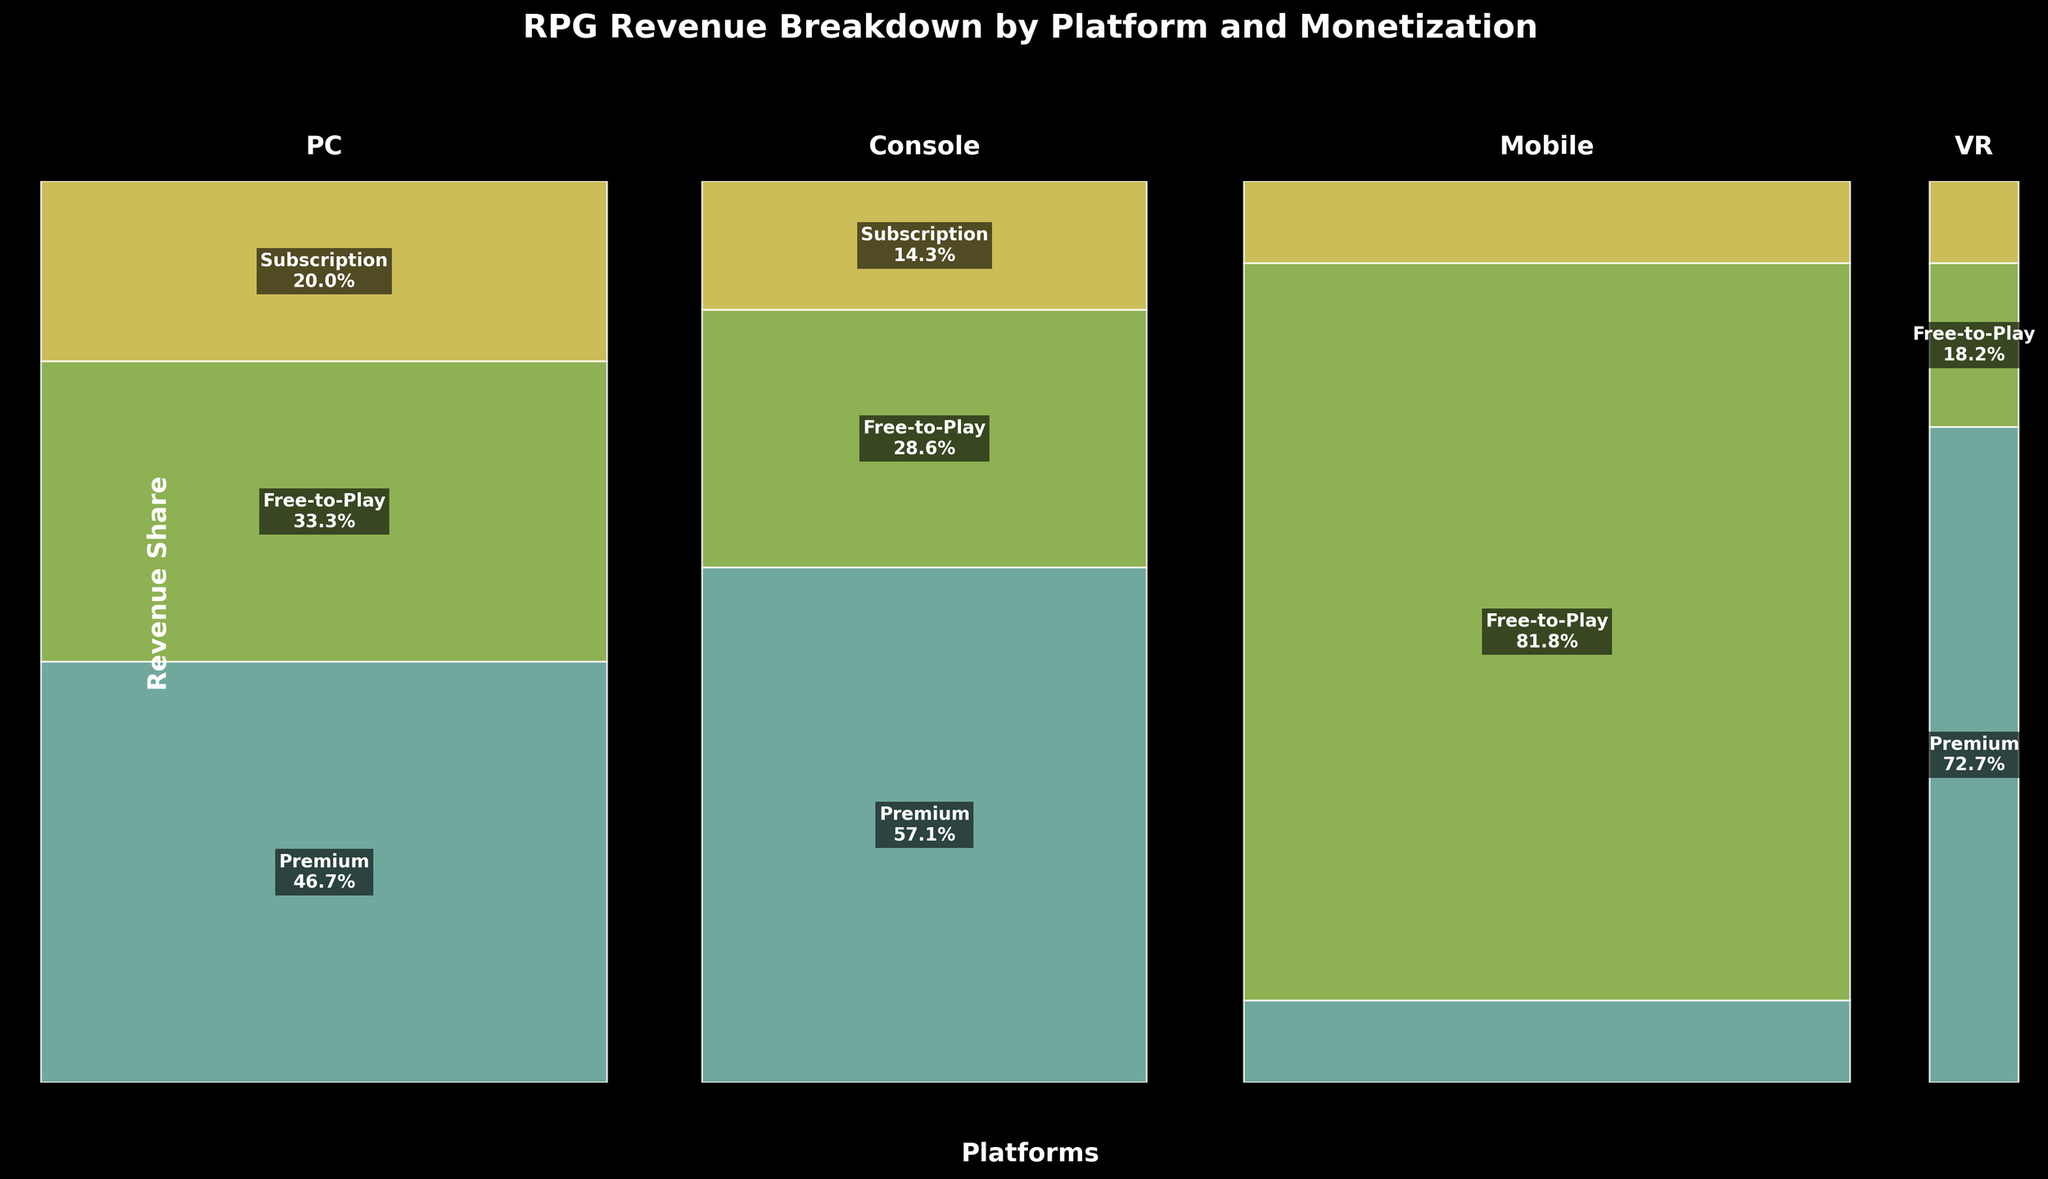Which platform generates the most revenue? By observing the height of the bars, Console appears to have the highest total revenue across all monetization models.
Answer: Console Which monetization model is the most profitable on mobile platforms? By observing the height of the stacking bars, Free-to-Play on the Mobile platform has the largest share of revenue.
Answer: Free-to-Play What's the total revenue share for Subscription models across all platforms? Summing up the heights of the Subscription segments across all platforms: 15 (PC) + 10 (Console) + 5 (Mobile) + 1 (VR) = 31
Answer: 31 On which platform does Premium generate the smallest revenue share? Among the bars labeled Premium, the smallest height is observed in the Mobile platform.
Answer: Mobile Between PC and Console platforms, which has a larger Free-to-Play revenue share? By comparing the heights of the Free-to-Play bars on PC and Console, PC has a higher Free-to-Play revenue share.
Answer: PC What percentage of the Console platform's revenue comes from Premium models? The Premium model covers a larger portion of the Console bar. Visually estimating, it covers about 80%.
Answer: 80% How do the revenue distributions on VR and Mobile platforms differ? VR has a relatively even distribution between Premium and Free-to-Play with hardly any Subscription, while Mobile has a dominant Free-to-Play segment with minimal share in Premium and Subscription.
Answer: VR is more balanced; Mobile is Free-to-Play dominant In terms of Premium revenue, which platform performs better: VR or Mobile? By observing the height of the Premium bars, VR generates more revenue than Mobile, albeit both are low.
Answer: VR Which platform has the smallest share of revenue coming from Free-to-Play? Observing the Free-to-Play bar heights, VR has the smallest share of revenue from Free-to-Play.
Answer: VR 